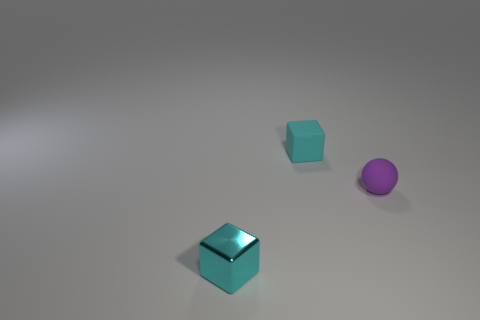Add 1 metallic cubes. How many objects exist? 4 Subtract all spheres. How many objects are left? 2 Subtract all cyan shiny objects. Subtract all cyan rubber objects. How many objects are left? 1 Add 1 cyan rubber objects. How many cyan rubber objects are left? 2 Add 2 large red metallic blocks. How many large red metallic blocks exist? 2 Subtract 0 yellow cylinders. How many objects are left? 3 